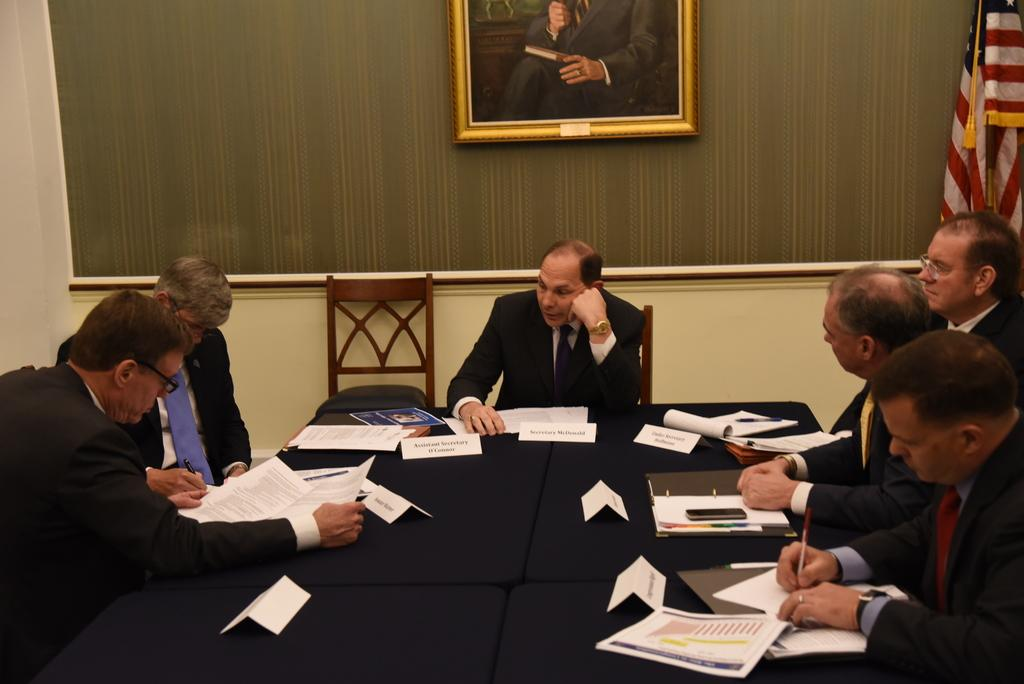What is happening in the image? There are people sitting around a table in the image. What objects are on the table? There are papers on the table. What can be seen in the background of the image? There is a flag in the background of the image. What is hanging on the wall in the image? There is a photo frame on the wall. What is the mass of the flag in the image? The mass of the flag cannot be determined from the image alone, as it depends on the material and size of the flag. 